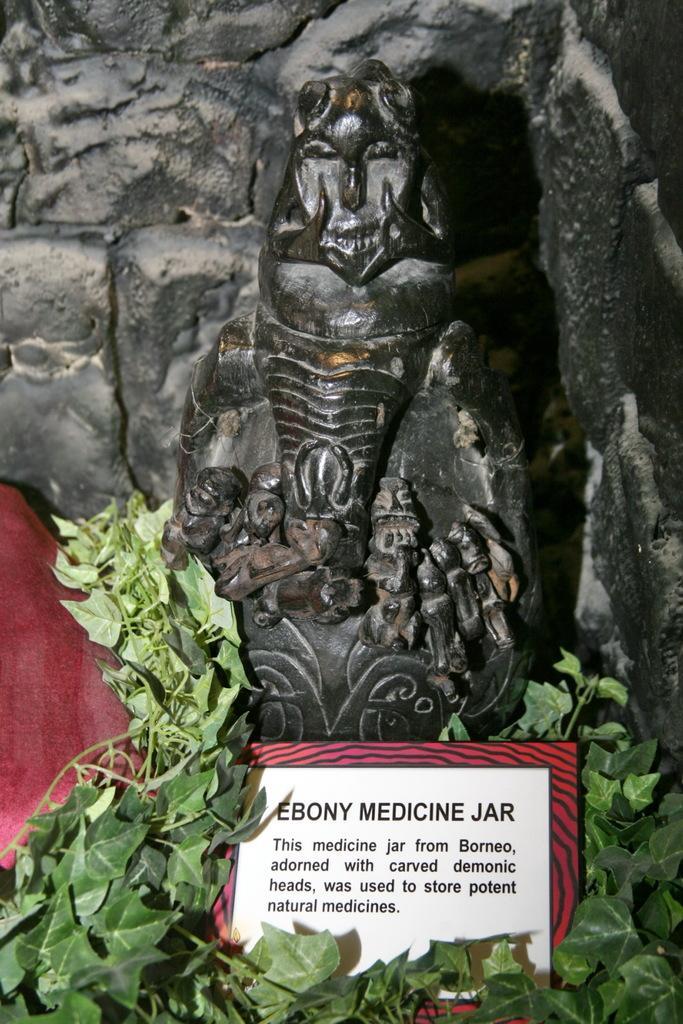How would you summarize this image in a sentence or two? This picture shows a statue and we see a plant and a board 